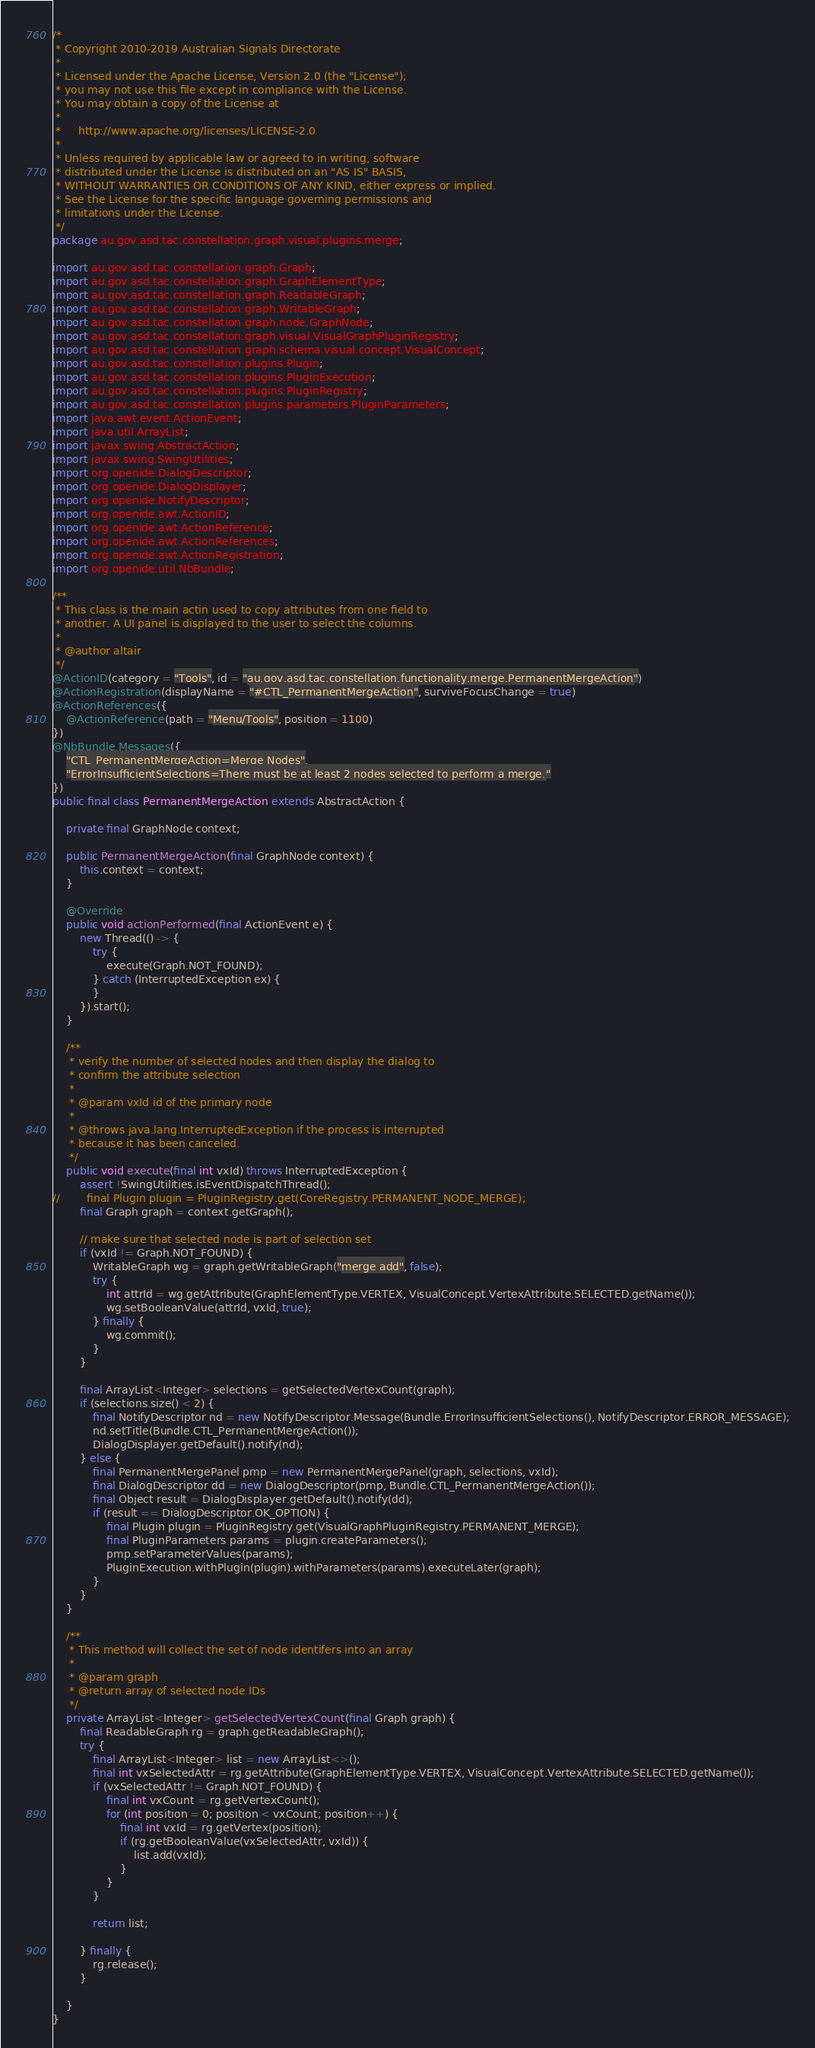<code> <loc_0><loc_0><loc_500><loc_500><_Java_>/*
 * Copyright 2010-2019 Australian Signals Directorate
 *
 * Licensed under the Apache License, Version 2.0 (the "License");
 * you may not use this file except in compliance with the License.
 * You may obtain a copy of the License at
 *
 *     http://www.apache.org/licenses/LICENSE-2.0
 *
 * Unless required by applicable law or agreed to in writing, software
 * distributed under the License is distributed on an "AS IS" BASIS,
 * WITHOUT WARRANTIES OR CONDITIONS OF ANY KIND, either express or implied.
 * See the License for the specific language governing permissions and
 * limitations under the License.
 */
package au.gov.asd.tac.constellation.graph.visual.plugins.merge;

import au.gov.asd.tac.constellation.graph.Graph;
import au.gov.asd.tac.constellation.graph.GraphElementType;
import au.gov.asd.tac.constellation.graph.ReadableGraph;
import au.gov.asd.tac.constellation.graph.WritableGraph;
import au.gov.asd.tac.constellation.graph.node.GraphNode;
import au.gov.asd.tac.constellation.graph.visual.VisualGraphPluginRegistry;
import au.gov.asd.tac.constellation.graph.schema.visual.concept.VisualConcept;
import au.gov.asd.tac.constellation.plugins.Plugin;
import au.gov.asd.tac.constellation.plugins.PluginExecution;
import au.gov.asd.tac.constellation.plugins.PluginRegistry;
import au.gov.asd.tac.constellation.plugins.parameters.PluginParameters;
import java.awt.event.ActionEvent;
import java.util.ArrayList;
import javax.swing.AbstractAction;
import javax.swing.SwingUtilities;
import org.openide.DialogDescriptor;
import org.openide.DialogDisplayer;
import org.openide.NotifyDescriptor;
import org.openide.awt.ActionID;
import org.openide.awt.ActionReference;
import org.openide.awt.ActionReferences;
import org.openide.awt.ActionRegistration;
import org.openide.util.NbBundle;

/**
 * This class is the main actin used to copy attributes from one field to
 * another. A UI panel is displayed to the user to select the columns.
 *
 * @author altair
 */
@ActionID(category = "Tools", id = "au.gov.asd.tac.constellation.functionality.merge.PermanentMergeAction")
@ActionRegistration(displayName = "#CTL_PermanentMergeAction", surviveFocusChange = true)
@ActionReferences({
    @ActionReference(path = "Menu/Tools", position = 1100)
})
@NbBundle.Messages({
    "CTL_PermanentMergeAction=Merge Nodes",
    "ErrorInsufficientSelections=There must be at least 2 nodes selected to perform a merge."
})
public final class PermanentMergeAction extends AbstractAction {

    private final GraphNode context;

    public PermanentMergeAction(final GraphNode context) {
        this.context = context;
    }

    @Override
    public void actionPerformed(final ActionEvent e) {
        new Thread(() -> {
            try {
                execute(Graph.NOT_FOUND);
            } catch (InterruptedException ex) {
            }
        }).start();
    }

    /**
     * verify the number of selected nodes and then display the dialog to
     * confirm the attribute selection
     *
     * @param vxId id of the primary node
     *
     * @throws java.lang.InterruptedException if the process is interrupted
     * because it has been canceled.
     */
    public void execute(final int vxId) throws InterruptedException {
        assert !SwingUtilities.isEventDispatchThread();
//        final Plugin plugin = PluginRegistry.get(CoreRegistry.PERMANENT_NODE_MERGE);
        final Graph graph = context.getGraph();

        // make sure that selected node is part of selection set
        if (vxId != Graph.NOT_FOUND) {
            WritableGraph wg = graph.getWritableGraph("merge add", false);
            try {
                int attrId = wg.getAttribute(GraphElementType.VERTEX, VisualConcept.VertexAttribute.SELECTED.getName());
                wg.setBooleanValue(attrId, vxId, true);
            } finally {
                wg.commit();
            }
        }

        final ArrayList<Integer> selections = getSelectedVertexCount(graph);
        if (selections.size() < 2) {
            final NotifyDescriptor nd = new NotifyDescriptor.Message(Bundle.ErrorInsufficientSelections(), NotifyDescriptor.ERROR_MESSAGE);
            nd.setTitle(Bundle.CTL_PermanentMergeAction());
            DialogDisplayer.getDefault().notify(nd);
        } else {
            final PermanentMergePanel pmp = new PermanentMergePanel(graph, selections, vxId);
            final DialogDescriptor dd = new DialogDescriptor(pmp, Bundle.CTL_PermanentMergeAction());
            final Object result = DialogDisplayer.getDefault().notify(dd);
            if (result == DialogDescriptor.OK_OPTION) {
                final Plugin plugin = PluginRegistry.get(VisualGraphPluginRegistry.PERMANENT_MERGE);
                final PluginParameters params = plugin.createParameters();
                pmp.setParameterValues(params);
                PluginExecution.withPlugin(plugin).withParameters(params).executeLater(graph);
            }
        }
    }

    /**
     * This method will collect the set of node identifers into an array
     *
     * @param graph
     * @return array of selected node IDs
     */
    private ArrayList<Integer> getSelectedVertexCount(final Graph graph) {
        final ReadableGraph rg = graph.getReadableGraph();
        try {
            final ArrayList<Integer> list = new ArrayList<>();
            final int vxSelectedAttr = rg.getAttribute(GraphElementType.VERTEX, VisualConcept.VertexAttribute.SELECTED.getName());
            if (vxSelectedAttr != Graph.NOT_FOUND) {
                final int vxCount = rg.getVertexCount();
                for (int position = 0; position < vxCount; position++) {
                    final int vxId = rg.getVertex(position);
                    if (rg.getBooleanValue(vxSelectedAttr, vxId)) {
                        list.add(vxId);
                    }
                }
            }

            return list;

        } finally {
            rg.release();
        }

    }
}
</code> 